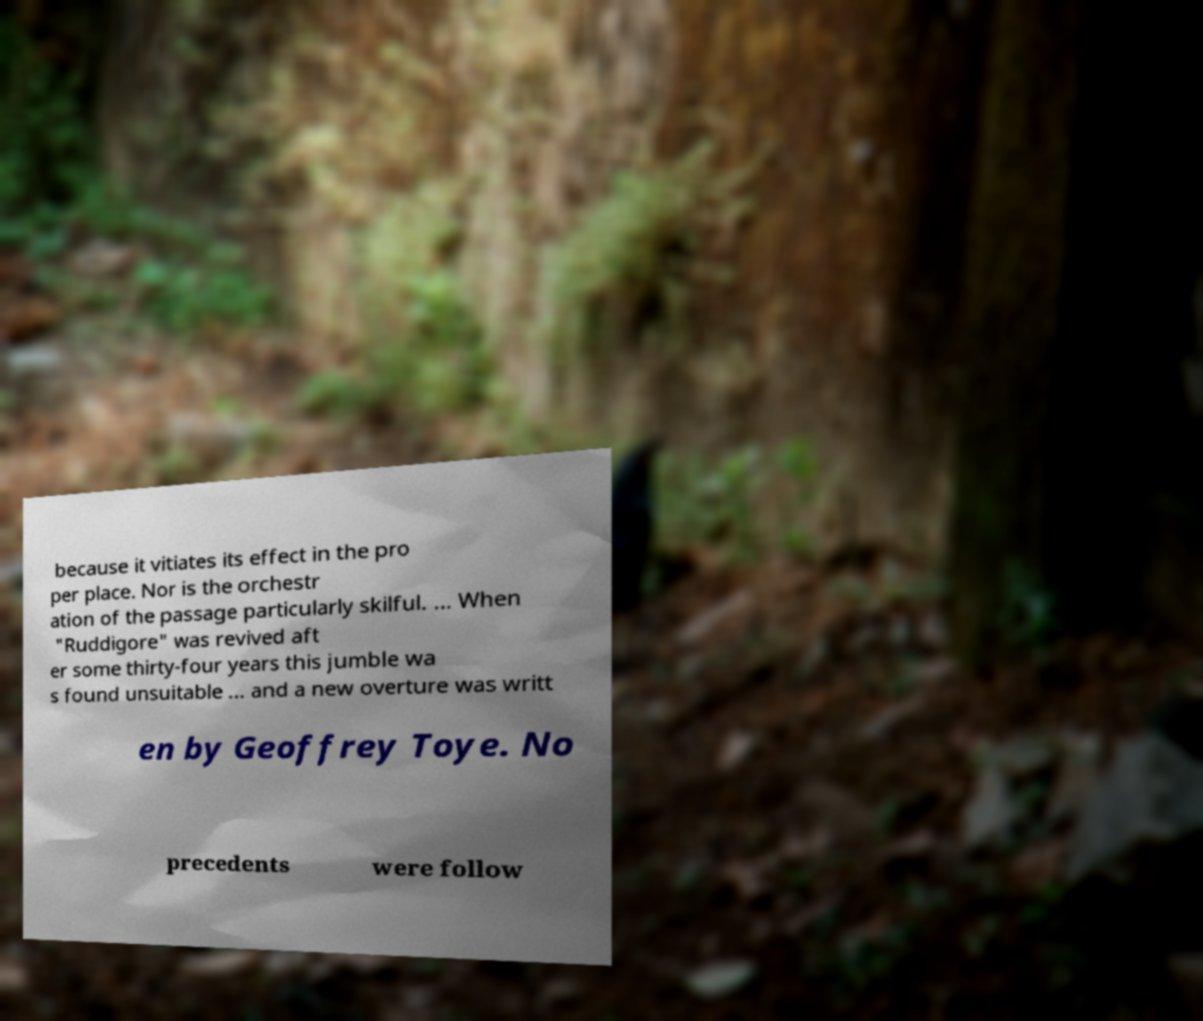Could you extract and type out the text from this image? because it vitiates its effect in the pro per place. Nor is the orchestr ation of the passage particularly skilful. ... When "Ruddigore" was revived aft er some thirty-four years this jumble wa s found unsuitable ... and a new overture was writt en by Geoffrey Toye. No precedents were follow 